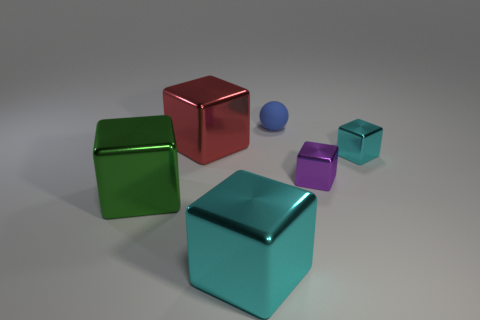Subtract all tiny purple cubes. How many cubes are left? 4 Subtract all yellow cubes. Subtract all blue cylinders. How many cubes are left? 5 Add 3 purple shiny cubes. How many objects exist? 9 Subtract all blocks. How many objects are left? 1 Add 1 blue balls. How many blue balls are left? 2 Add 5 tiny blue spheres. How many tiny blue spheres exist? 6 Subtract 1 blue balls. How many objects are left? 5 Subtract all small purple metallic things. Subtract all big green objects. How many objects are left? 4 